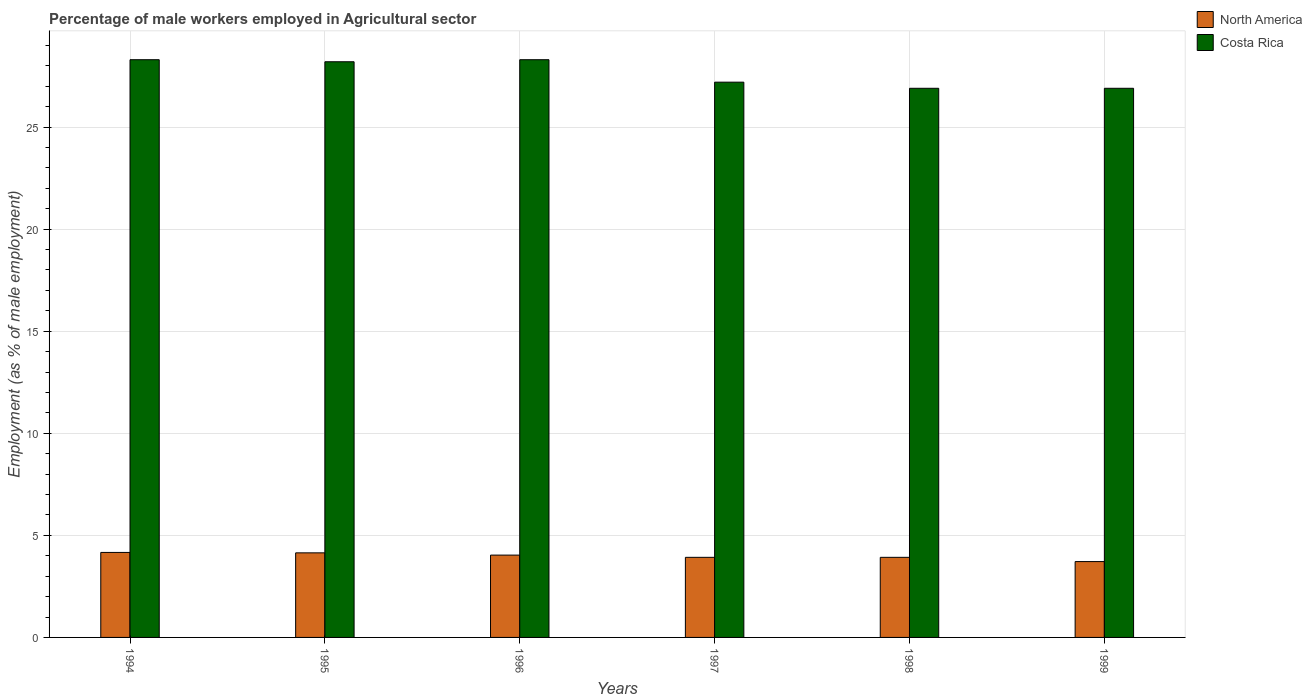How many groups of bars are there?
Your answer should be very brief. 6. What is the label of the 3rd group of bars from the left?
Provide a short and direct response. 1996. What is the percentage of male workers employed in Agricultural sector in North America in 1998?
Provide a short and direct response. 3.92. Across all years, what is the maximum percentage of male workers employed in Agricultural sector in North America?
Provide a short and direct response. 4.16. Across all years, what is the minimum percentage of male workers employed in Agricultural sector in North America?
Your answer should be very brief. 3.71. What is the total percentage of male workers employed in Agricultural sector in North America in the graph?
Make the answer very short. 23.9. What is the difference between the percentage of male workers employed in Agricultural sector in Costa Rica in 1997 and that in 1999?
Give a very brief answer. 0.3. What is the difference between the percentage of male workers employed in Agricultural sector in North America in 1996 and the percentage of male workers employed in Agricultural sector in Costa Rica in 1994?
Ensure brevity in your answer.  -24.27. What is the average percentage of male workers employed in Agricultural sector in North America per year?
Offer a terse response. 3.98. In the year 1994, what is the difference between the percentage of male workers employed in Agricultural sector in North America and percentage of male workers employed in Agricultural sector in Costa Rica?
Your answer should be compact. -24.14. In how many years, is the percentage of male workers employed in Agricultural sector in North America greater than 4 %?
Provide a short and direct response. 3. What is the ratio of the percentage of male workers employed in Agricultural sector in Costa Rica in 1997 to that in 1999?
Make the answer very short. 1.01. Is the percentage of male workers employed in Agricultural sector in North America in 1997 less than that in 1998?
Your answer should be compact. Yes. What is the difference between the highest and the lowest percentage of male workers employed in Agricultural sector in North America?
Your answer should be very brief. 0.45. Is the sum of the percentage of male workers employed in Agricultural sector in North America in 1994 and 1999 greater than the maximum percentage of male workers employed in Agricultural sector in Costa Rica across all years?
Your answer should be very brief. No. What does the 2nd bar from the right in 1997 represents?
Your answer should be very brief. North America. How many bars are there?
Keep it short and to the point. 12. Are the values on the major ticks of Y-axis written in scientific E-notation?
Ensure brevity in your answer.  No. What is the title of the graph?
Provide a short and direct response. Percentage of male workers employed in Agricultural sector. What is the label or title of the X-axis?
Your answer should be compact. Years. What is the label or title of the Y-axis?
Give a very brief answer. Employment (as % of male employment). What is the Employment (as % of male employment) of North America in 1994?
Offer a very short reply. 4.16. What is the Employment (as % of male employment) in Costa Rica in 1994?
Your answer should be compact. 28.3. What is the Employment (as % of male employment) of North America in 1995?
Provide a short and direct response. 4.14. What is the Employment (as % of male employment) in Costa Rica in 1995?
Your response must be concise. 28.2. What is the Employment (as % of male employment) in North America in 1996?
Provide a short and direct response. 4.03. What is the Employment (as % of male employment) in Costa Rica in 1996?
Give a very brief answer. 28.3. What is the Employment (as % of male employment) in North America in 1997?
Your answer should be very brief. 3.92. What is the Employment (as % of male employment) in Costa Rica in 1997?
Your response must be concise. 27.2. What is the Employment (as % of male employment) of North America in 1998?
Offer a very short reply. 3.92. What is the Employment (as % of male employment) in Costa Rica in 1998?
Make the answer very short. 26.9. What is the Employment (as % of male employment) in North America in 1999?
Your answer should be compact. 3.71. What is the Employment (as % of male employment) in Costa Rica in 1999?
Give a very brief answer. 26.9. Across all years, what is the maximum Employment (as % of male employment) in North America?
Offer a terse response. 4.16. Across all years, what is the maximum Employment (as % of male employment) of Costa Rica?
Give a very brief answer. 28.3. Across all years, what is the minimum Employment (as % of male employment) in North America?
Make the answer very short. 3.71. Across all years, what is the minimum Employment (as % of male employment) of Costa Rica?
Your response must be concise. 26.9. What is the total Employment (as % of male employment) of North America in the graph?
Give a very brief answer. 23.9. What is the total Employment (as % of male employment) in Costa Rica in the graph?
Your answer should be very brief. 165.8. What is the difference between the Employment (as % of male employment) in North America in 1994 and that in 1995?
Your answer should be compact. 0.02. What is the difference between the Employment (as % of male employment) of Costa Rica in 1994 and that in 1995?
Provide a succinct answer. 0.1. What is the difference between the Employment (as % of male employment) of North America in 1994 and that in 1996?
Give a very brief answer. 0.13. What is the difference between the Employment (as % of male employment) of Costa Rica in 1994 and that in 1996?
Provide a short and direct response. 0. What is the difference between the Employment (as % of male employment) of North America in 1994 and that in 1997?
Offer a very short reply. 0.24. What is the difference between the Employment (as % of male employment) in Costa Rica in 1994 and that in 1997?
Provide a succinct answer. 1.1. What is the difference between the Employment (as % of male employment) in North America in 1994 and that in 1998?
Offer a terse response. 0.24. What is the difference between the Employment (as % of male employment) of North America in 1994 and that in 1999?
Give a very brief answer. 0.45. What is the difference between the Employment (as % of male employment) of Costa Rica in 1994 and that in 1999?
Your answer should be very brief. 1.4. What is the difference between the Employment (as % of male employment) of North America in 1995 and that in 1996?
Provide a short and direct response. 0.11. What is the difference between the Employment (as % of male employment) in North America in 1995 and that in 1997?
Keep it short and to the point. 0.22. What is the difference between the Employment (as % of male employment) in Costa Rica in 1995 and that in 1997?
Your answer should be compact. 1. What is the difference between the Employment (as % of male employment) of North America in 1995 and that in 1998?
Keep it short and to the point. 0.22. What is the difference between the Employment (as % of male employment) in Costa Rica in 1995 and that in 1998?
Offer a terse response. 1.3. What is the difference between the Employment (as % of male employment) in North America in 1995 and that in 1999?
Make the answer very short. 0.43. What is the difference between the Employment (as % of male employment) of Costa Rica in 1995 and that in 1999?
Offer a very short reply. 1.3. What is the difference between the Employment (as % of male employment) of North America in 1996 and that in 1997?
Give a very brief answer. 0.11. What is the difference between the Employment (as % of male employment) of Costa Rica in 1996 and that in 1997?
Offer a very short reply. 1.1. What is the difference between the Employment (as % of male employment) in North America in 1996 and that in 1998?
Provide a short and direct response. 0.11. What is the difference between the Employment (as % of male employment) of North America in 1996 and that in 1999?
Give a very brief answer. 0.32. What is the difference between the Employment (as % of male employment) of North America in 1997 and that in 1999?
Your answer should be very brief. 0.21. What is the difference between the Employment (as % of male employment) in Costa Rica in 1997 and that in 1999?
Give a very brief answer. 0.3. What is the difference between the Employment (as % of male employment) of North America in 1998 and that in 1999?
Give a very brief answer. 0.21. What is the difference between the Employment (as % of male employment) in Costa Rica in 1998 and that in 1999?
Offer a terse response. 0. What is the difference between the Employment (as % of male employment) in North America in 1994 and the Employment (as % of male employment) in Costa Rica in 1995?
Give a very brief answer. -24.04. What is the difference between the Employment (as % of male employment) of North America in 1994 and the Employment (as % of male employment) of Costa Rica in 1996?
Your answer should be very brief. -24.14. What is the difference between the Employment (as % of male employment) in North America in 1994 and the Employment (as % of male employment) in Costa Rica in 1997?
Provide a succinct answer. -23.04. What is the difference between the Employment (as % of male employment) in North America in 1994 and the Employment (as % of male employment) in Costa Rica in 1998?
Give a very brief answer. -22.74. What is the difference between the Employment (as % of male employment) in North America in 1994 and the Employment (as % of male employment) in Costa Rica in 1999?
Your response must be concise. -22.74. What is the difference between the Employment (as % of male employment) of North America in 1995 and the Employment (as % of male employment) of Costa Rica in 1996?
Ensure brevity in your answer.  -24.16. What is the difference between the Employment (as % of male employment) of North America in 1995 and the Employment (as % of male employment) of Costa Rica in 1997?
Provide a succinct answer. -23.06. What is the difference between the Employment (as % of male employment) in North America in 1995 and the Employment (as % of male employment) in Costa Rica in 1998?
Keep it short and to the point. -22.76. What is the difference between the Employment (as % of male employment) in North America in 1995 and the Employment (as % of male employment) in Costa Rica in 1999?
Your answer should be compact. -22.76. What is the difference between the Employment (as % of male employment) of North America in 1996 and the Employment (as % of male employment) of Costa Rica in 1997?
Provide a short and direct response. -23.17. What is the difference between the Employment (as % of male employment) of North America in 1996 and the Employment (as % of male employment) of Costa Rica in 1998?
Ensure brevity in your answer.  -22.87. What is the difference between the Employment (as % of male employment) of North America in 1996 and the Employment (as % of male employment) of Costa Rica in 1999?
Ensure brevity in your answer.  -22.87. What is the difference between the Employment (as % of male employment) in North America in 1997 and the Employment (as % of male employment) in Costa Rica in 1998?
Your response must be concise. -22.98. What is the difference between the Employment (as % of male employment) in North America in 1997 and the Employment (as % of male employment) in Costa Rica in 1999?
Provide a succinct answer. -22.98. What is the difference between the Employment (as % of male employment) of North America in 1998 and the Employment (as % of male employment) of Costa Rica in 1999?
Offer a very short reply. -22.98. What is the average Employment (as % of male employment) in North America per year?
Your answer should be compact. 3.98. What is the average Employment (as % of male employment) of Costa Rica per year?
Ensure brevity in your answer.  27.63. In the year 1994, what is the difference between the Employment (as % of male employment) in North America and Employment (as % of male employment) in Costa Rica?
Your answer should be compact. -24.14. In the year 1995, what is the difference between the Employment (as % of male employment) of North America and Employment (as % of male employment) of Costa Rica?
Provide a succinct answer. -24.06. In the year 1996, what is the difference between the Employment (as % of male employment) in North America and Employment (as % of male employment) in Costa Rica?
Give a very brief answer. -24.27. In the year 1997, what is the difference between the Employment (as % of male employment) of North America and Employment (as % of male employment) of Costa Rica?
Provide a succinct answer. -23.28. In the year 1998, what is the difference between the Employment (as % of male employment) in North America and Employment (as % of male employment) in Costa Rica?
Give a very brief answer. -22.98. In the year 1999, what is the difference between the Employment (as % of male employment) of North America and Employment (as % of male employment) of Costa Rica?
Keep it short and to the point. -23.19. What is the ratio of the Employment (as % of male employment) in Costa Rica in 1994 to that in 1995?
Make the answer very short. 1. What is the ratio of the Employment (as % of male employment) of North America in 1994 to that in 1996?
Provide a short and direct response. 1.03. What is the ratio of the Employment (as % of male employment) in North America in 1994 to that in 1997?
Give a very brief answer. 1.06. What is the ratio of the Employment (as % of male employment) in Costa Rica in 1994 to that in 1997?
Your answer should be very brief. 1.04. What is the ratio of the Employment (as % of male employment) in North America in 1994 to that in 1998?
Your answer should be compact. 1.06. What is the ratio of the Employment (as % of male employment) in Costa Rica in 1994 to that in 1998?
Your answer should be compact. 1.05. What is the ratio of the Employment (as % of male employment) in North America in 1994 to that in 1999?
Offer a terse response. 1.12. What is the ratio of the Employment (as % of male employment) of Costa Rica in 1994 to that in 1999?
Ensure brevity in your answer.  1.05. What is the ratio of the Employment (as % of male employment) in North America in 1995 to that in 1996?
Give a very brief answer. 1.03. What is the ratio of the Employment (as % of male employment) in Costa Rica in 1995 to that in 1996?
Your answer should be compact. 1. What is the ratio of the Employment (as % of male employment) of North America in 1995 to that in 1997?
Give a very brief answer. 1.06. What is the ratio of the Employment (as % of male employment) in Costa Rica in 1995 to that in 1997?
Offer a terse response. 1.04. What is the ratio of the Employment (as % of male employment) of North America in 1995 to that in 1998?
Give a very brief answer. 1.06. What is the ratio of the Employment (as % of male employment) of Costa Rica in 1995 to that in 1998?
Make the answer very short. 1.05. What is the ratio of the Employment (as % of male employment) of North America in 1995 to that in 1999?
Provide a succinct answer. 1.12. What is the ratio of the Employment (as % of male employment) of Costa Rica in 1995 to that in 1999?
Your answer should be very brief. 1.05. What is the ratio of the Employment (as % of male employment) of North America in 1996 to that in 1997?
Offer a very short reply. 1.03. What is the ratio of the Employment (as % of male employment) of Costa Rica in 1996 to that in 1997?
Provide a succinct answer. 1.04. What is the ratio of the Employment (as % of male employment) of North America in 1996 to that in 1998?
Your response must be concise. 1.03. What is the ratio of the Employment (as % of male employment) in Costa Rica in 1996 to that in 1998?
Give a very brief answer. 1.05. What is the ratio of the Employment (as % of male employment) of North America in 1996 to that in 1999?
Your answer should be compact. 1.09. What is the ratio of the Employment (as % of male employment) in Costa Rica in 1996 to that in 1999?
Offer a terse response. 1.05. What is the ratio of the Employment (as % of male employment) of Costa Rica in 1997 to that in 1998?
Your answer should be compact. 1.01. What is the ratio of the Employment (as % of male employment) in North America in 1997 to that in 1999?
Your answer should be compact. 1.06. What is the ratio of the Employment (as % of male employment) of Costa Rica in 1997 to that in 1999?
Make the answer very short. 1.01. What is the ratio of the Employment (as % of male employment) of North America in 1998 to that in 1999?
Provide a short and direct response. 1.06. What is the difference between the highest and the second highest Employment (as % of male employment) of North America?
Provide a short and direct response. 0.02. What is the difference between the highest and the lowest Employment (as % of male employment) of North America?
Provide a short and direct response. 0.45. What is the difference between the highest and the lowest Employment (as % of male employment) in Costa Rica?
Provide a succinct answer. 1.4. 